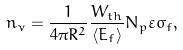<formula> <loc_0><loc_0><loc_500><loc_500>n _ { \nu } = \frac { 1 } { 4 \pi R ^ { 2 } } \frac { W _ { t h } } { \langle E _ { f } \rangle } N _ { p } \varepsilon \sigma _ { f } ,</formula> 